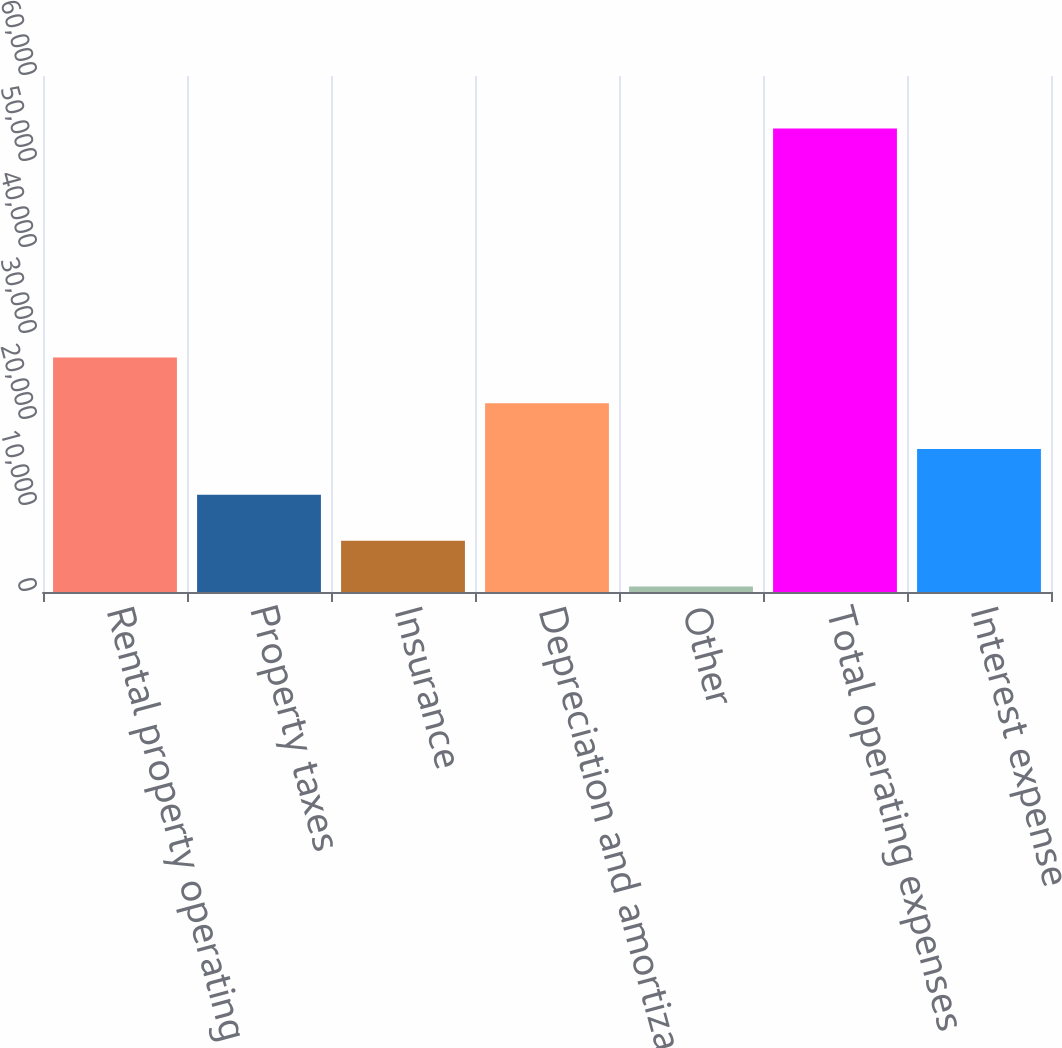Convert chart. <chart><loc_0><loc_0><loc_500><loc_500><bar_chart><fcel>Rental property operating and<fcel>Property taxes<fcel>Insurance<fcel>Depreciation and amortization<fcel>Other<fcel>Total operating expenses<fcel>Interest expense<nl><fcel>27273<fcel>11296.2<fcel>5970.6<fcel>21947.4<fcel>645<fcel>53901<fcel>16621.8<nl></chart> 